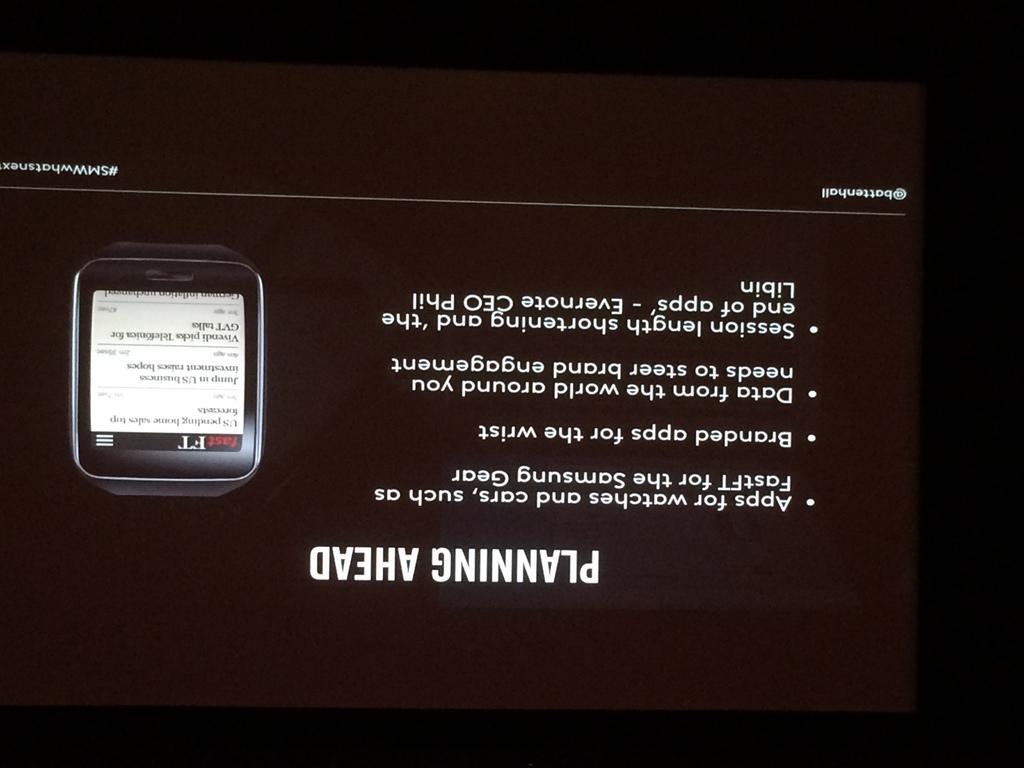What phrase does it say on the bottom?
Offer a very short reply. Planning ahead. What is for "watches and cars"?
Your answer should be compact. Apps. 